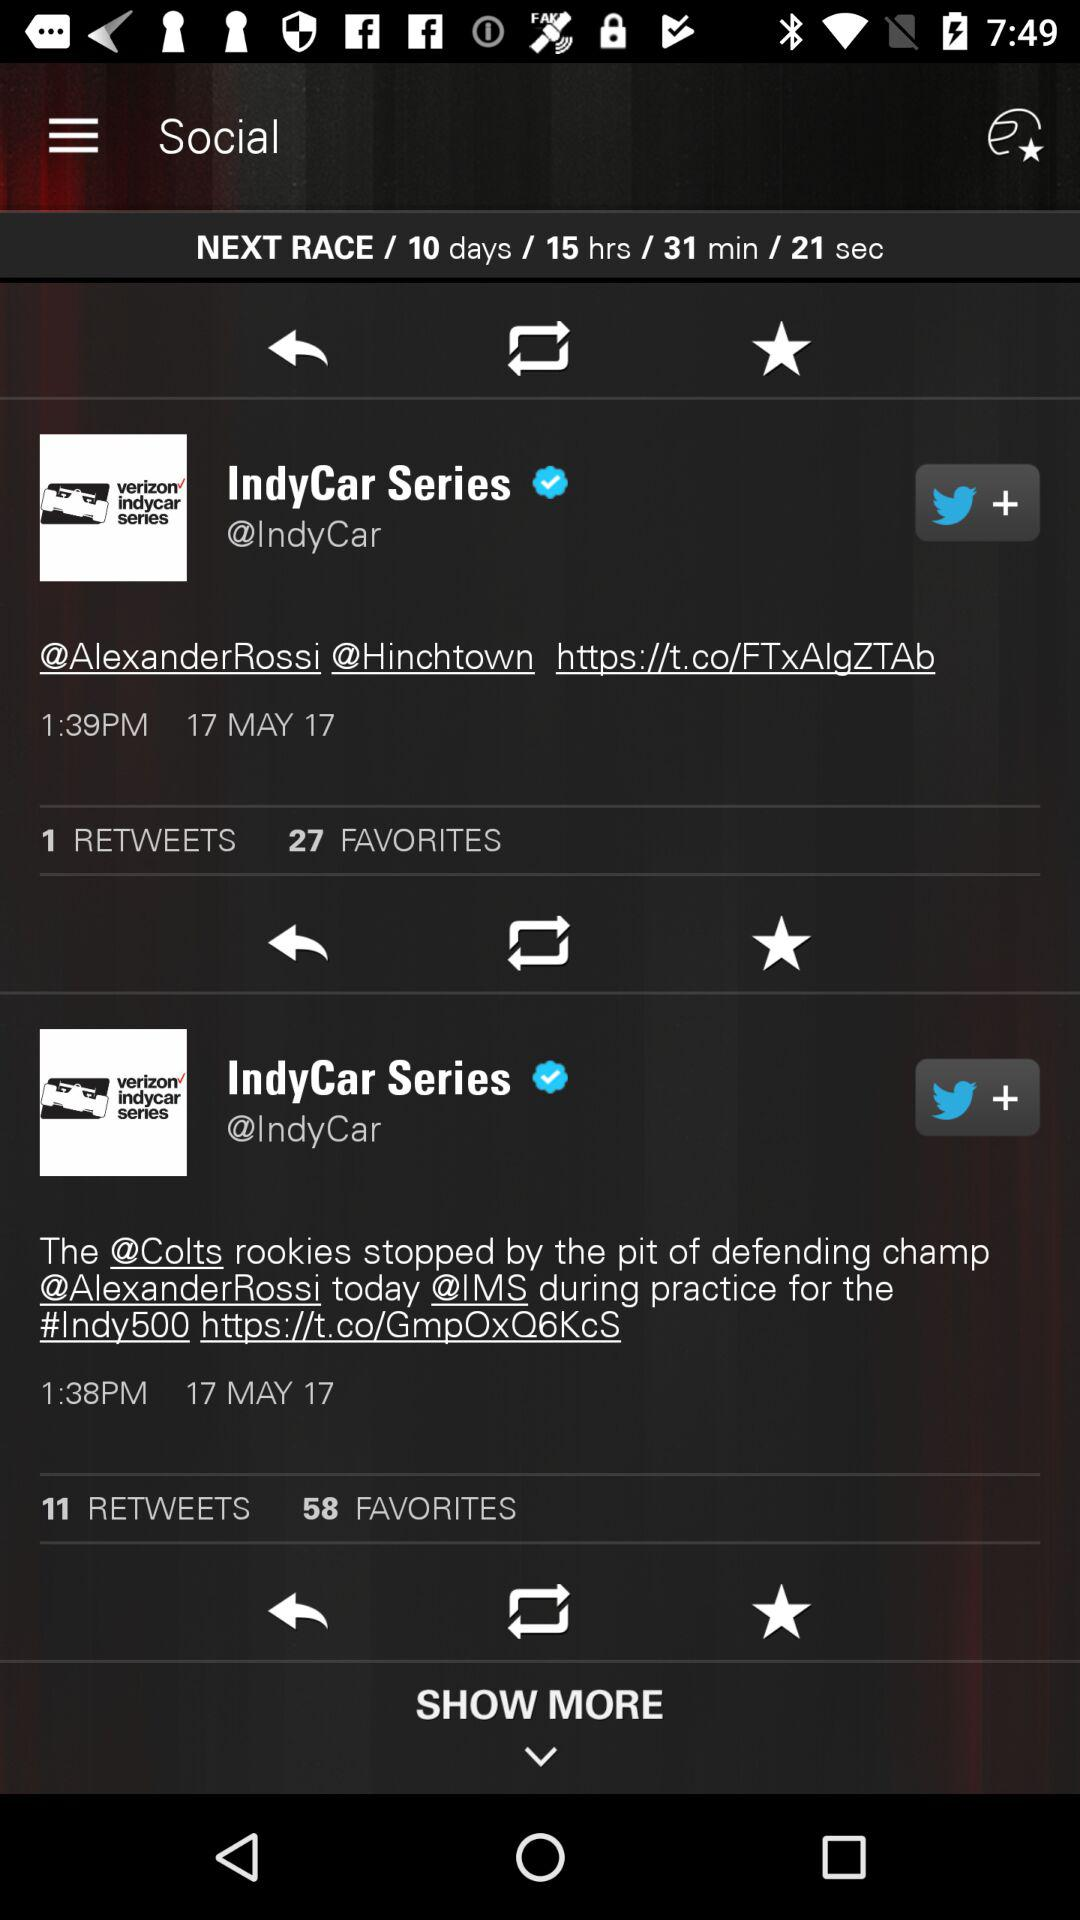How long should I wait for the next race? You should wait 10 days 15 hours 31 minutes 21 seconds for the next race. 